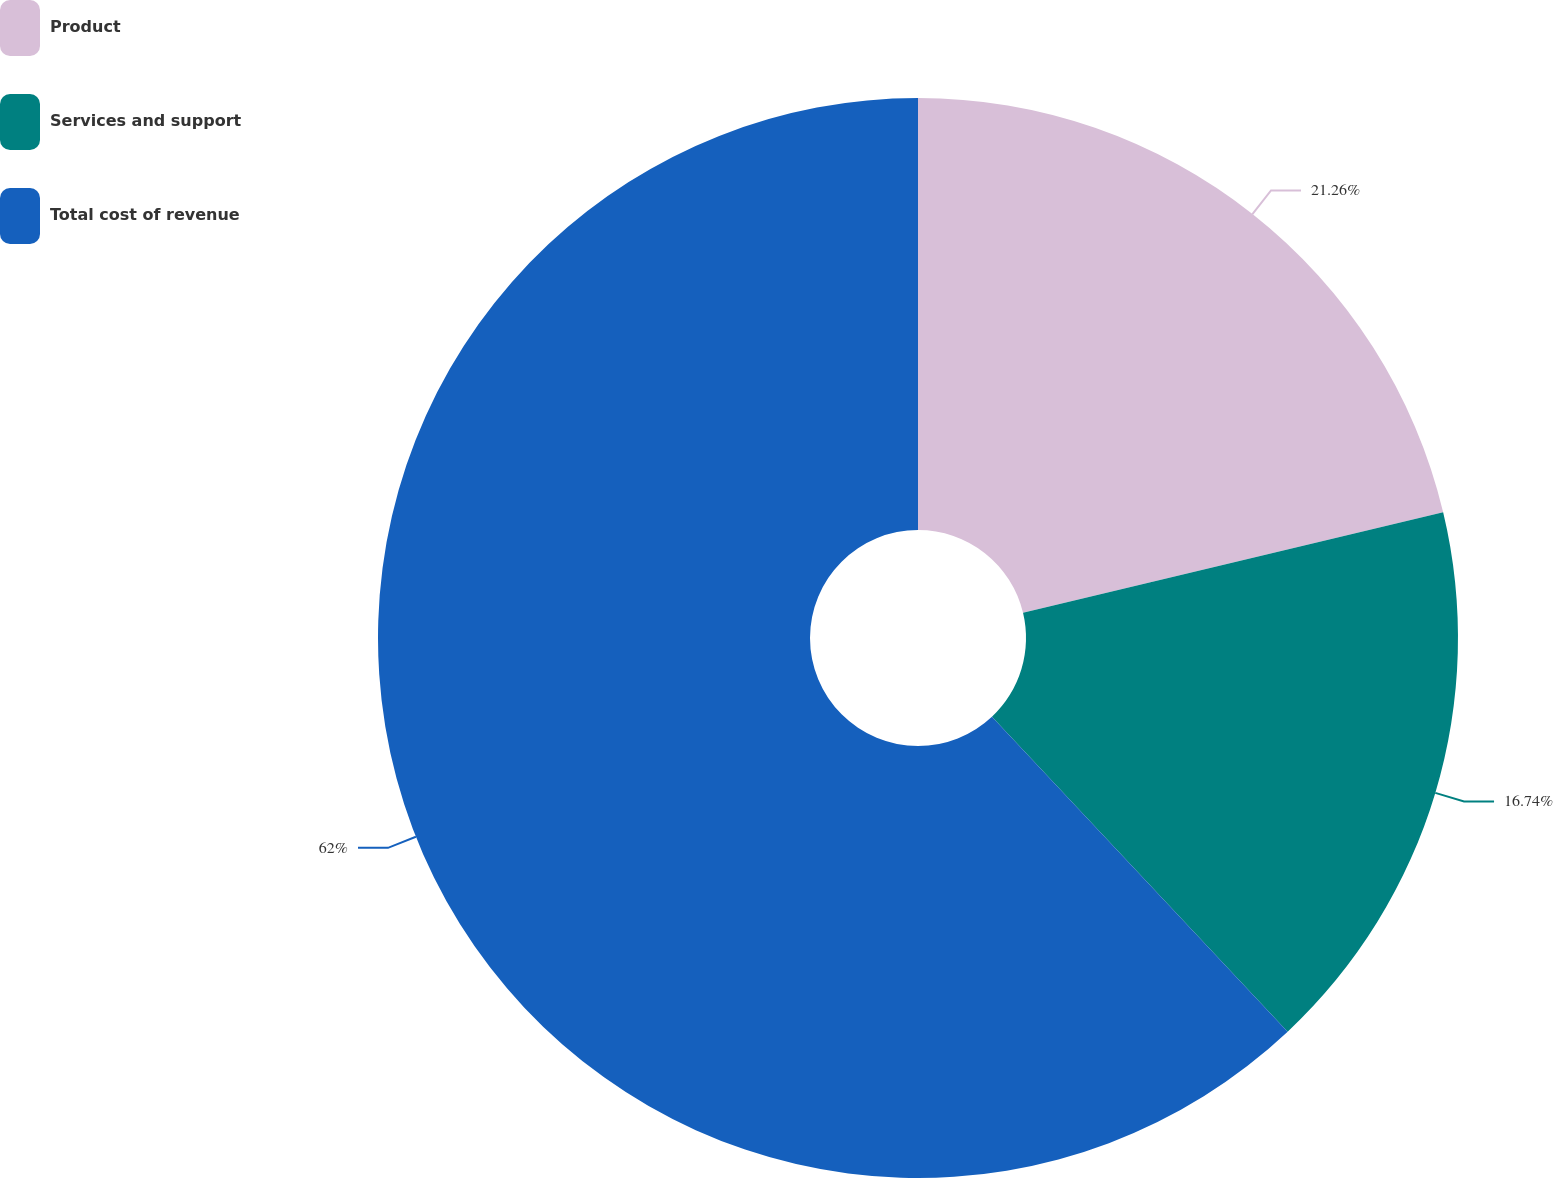Convert chart to OTSL. <chart><loc_0><loc_0><loc_500><loc_500><pie_chart><fcel>Product<fcel>Services and support<fcel>Total cost of revenue<nl><fcel>21.26%<fcel>16.74%<fcel>62.0%<nl></chart> 